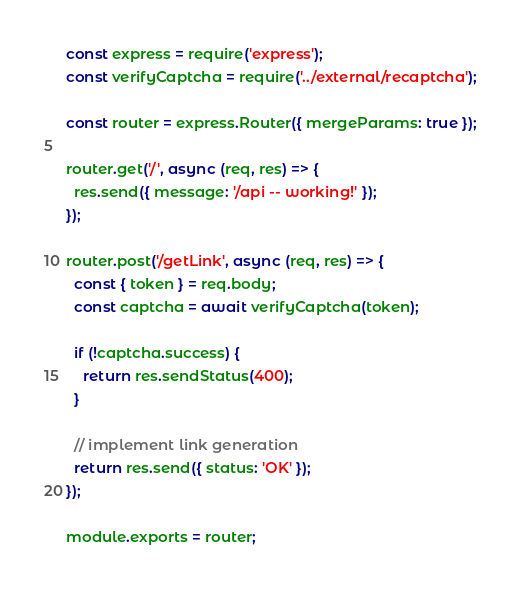<code> <loc_0><loc_0><loc_500><loc_500><_JavaScript_>const express = require('express');
const verifyCaptcha = require('../external/recaptcha');

const router = express.Router({ mergeParams: true });

router.get('/', async (req, res) => {
  res.send({ message: '/api -- working!' });
});

router.post('/getLink', async (req, res) => {
  const { token } = req.body;
  const captcha = await verifyCaptcha(token);

  if (!captcha.success) {
    return res.sendStatus(400);
  }

  // implement link generation
  return res.send({ status: 'OK' });
});

module.exports = router;
</code> 